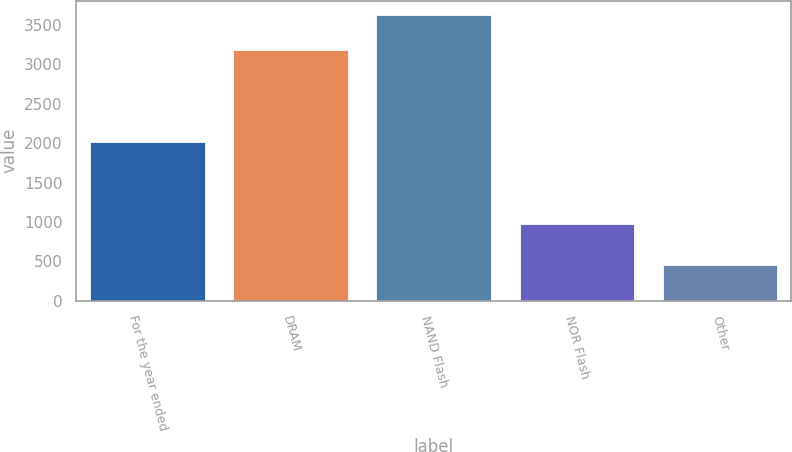Convert chart to OTSL. <chart><loc_0><loc_0><loc_500><loc_500><bar_chart><fcel>For the year ended<fcel>DRAM<fcel>NAND Flash<fcel>NOR Flash<fcel>Other<nl><fcel>2012<fcel>3178<fcel>3627<fcel>977<fcel>452<nl></chart> 